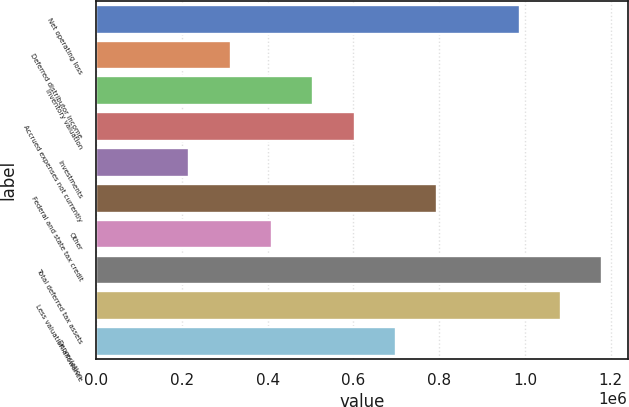<chart> <loc_0><loc_0><loc_500><loc_500><bar_chart><fcel>Net operating loss<fcel>Deferred distributor income<fcel>Inventory valuation<fcel>Accrued expenses not currently<fcel>Investments<fcel>Federal and state tax credit<fcel>Other<fcel>Total deferred tax assets<fcel>Less valuation allowance<fcel>Depreciation<nl><fcel>987710<fcel>313540<fcel>506160<fcel>602470<fcel>217230<fcel>795090<fcel>409850<fcel>1.18033e+06<fcel>1.08402e+06<fcel>698780<nl></chart> 